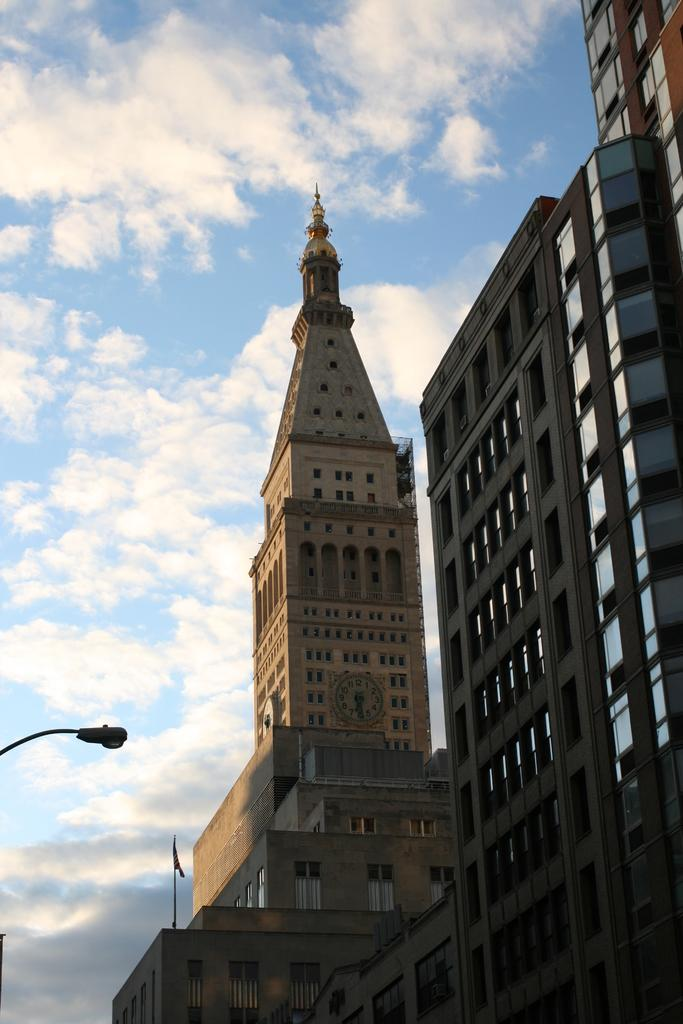What type of structures can be seen in the image? There are buildings in the image. Can you describe the lighting conditions in the image? There is light visible in the image. What is attached to the flag in the image? The flag has a pole in the image. What is visible in the background of the image? The sky is visible in the image, and there are clouds in the sky. What type of pets are visible in the image? There are no pets visible in the image. What type of instrument is being played in the image? There is no instrument being played in the image. 